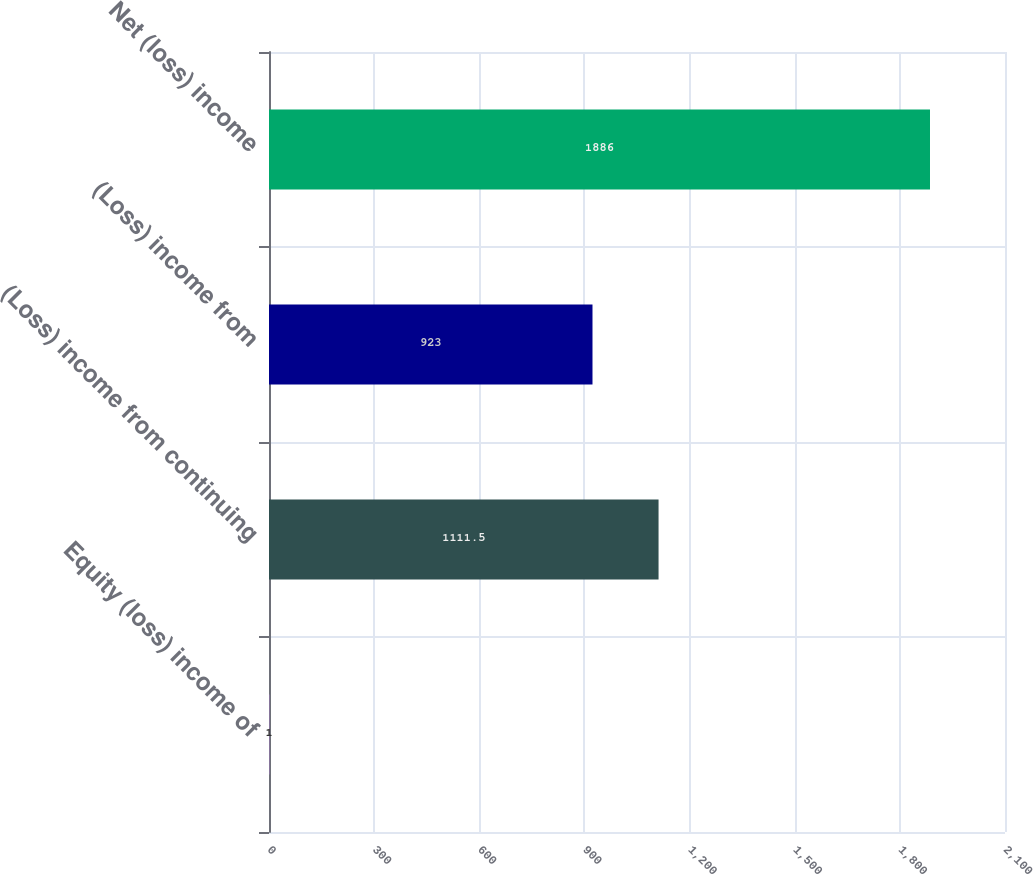<chart> <loc_0><loc_0><loc_500><loc_500><bar_chart><fcel>Equity (loss) income of<fcel>(Loss) income from continuing<fcel>(Loss) income from<fcel>Net (loss) income<nl><fcel>1<fcel>1111.5<fcel>923<fcel>1886<nl></chart> 